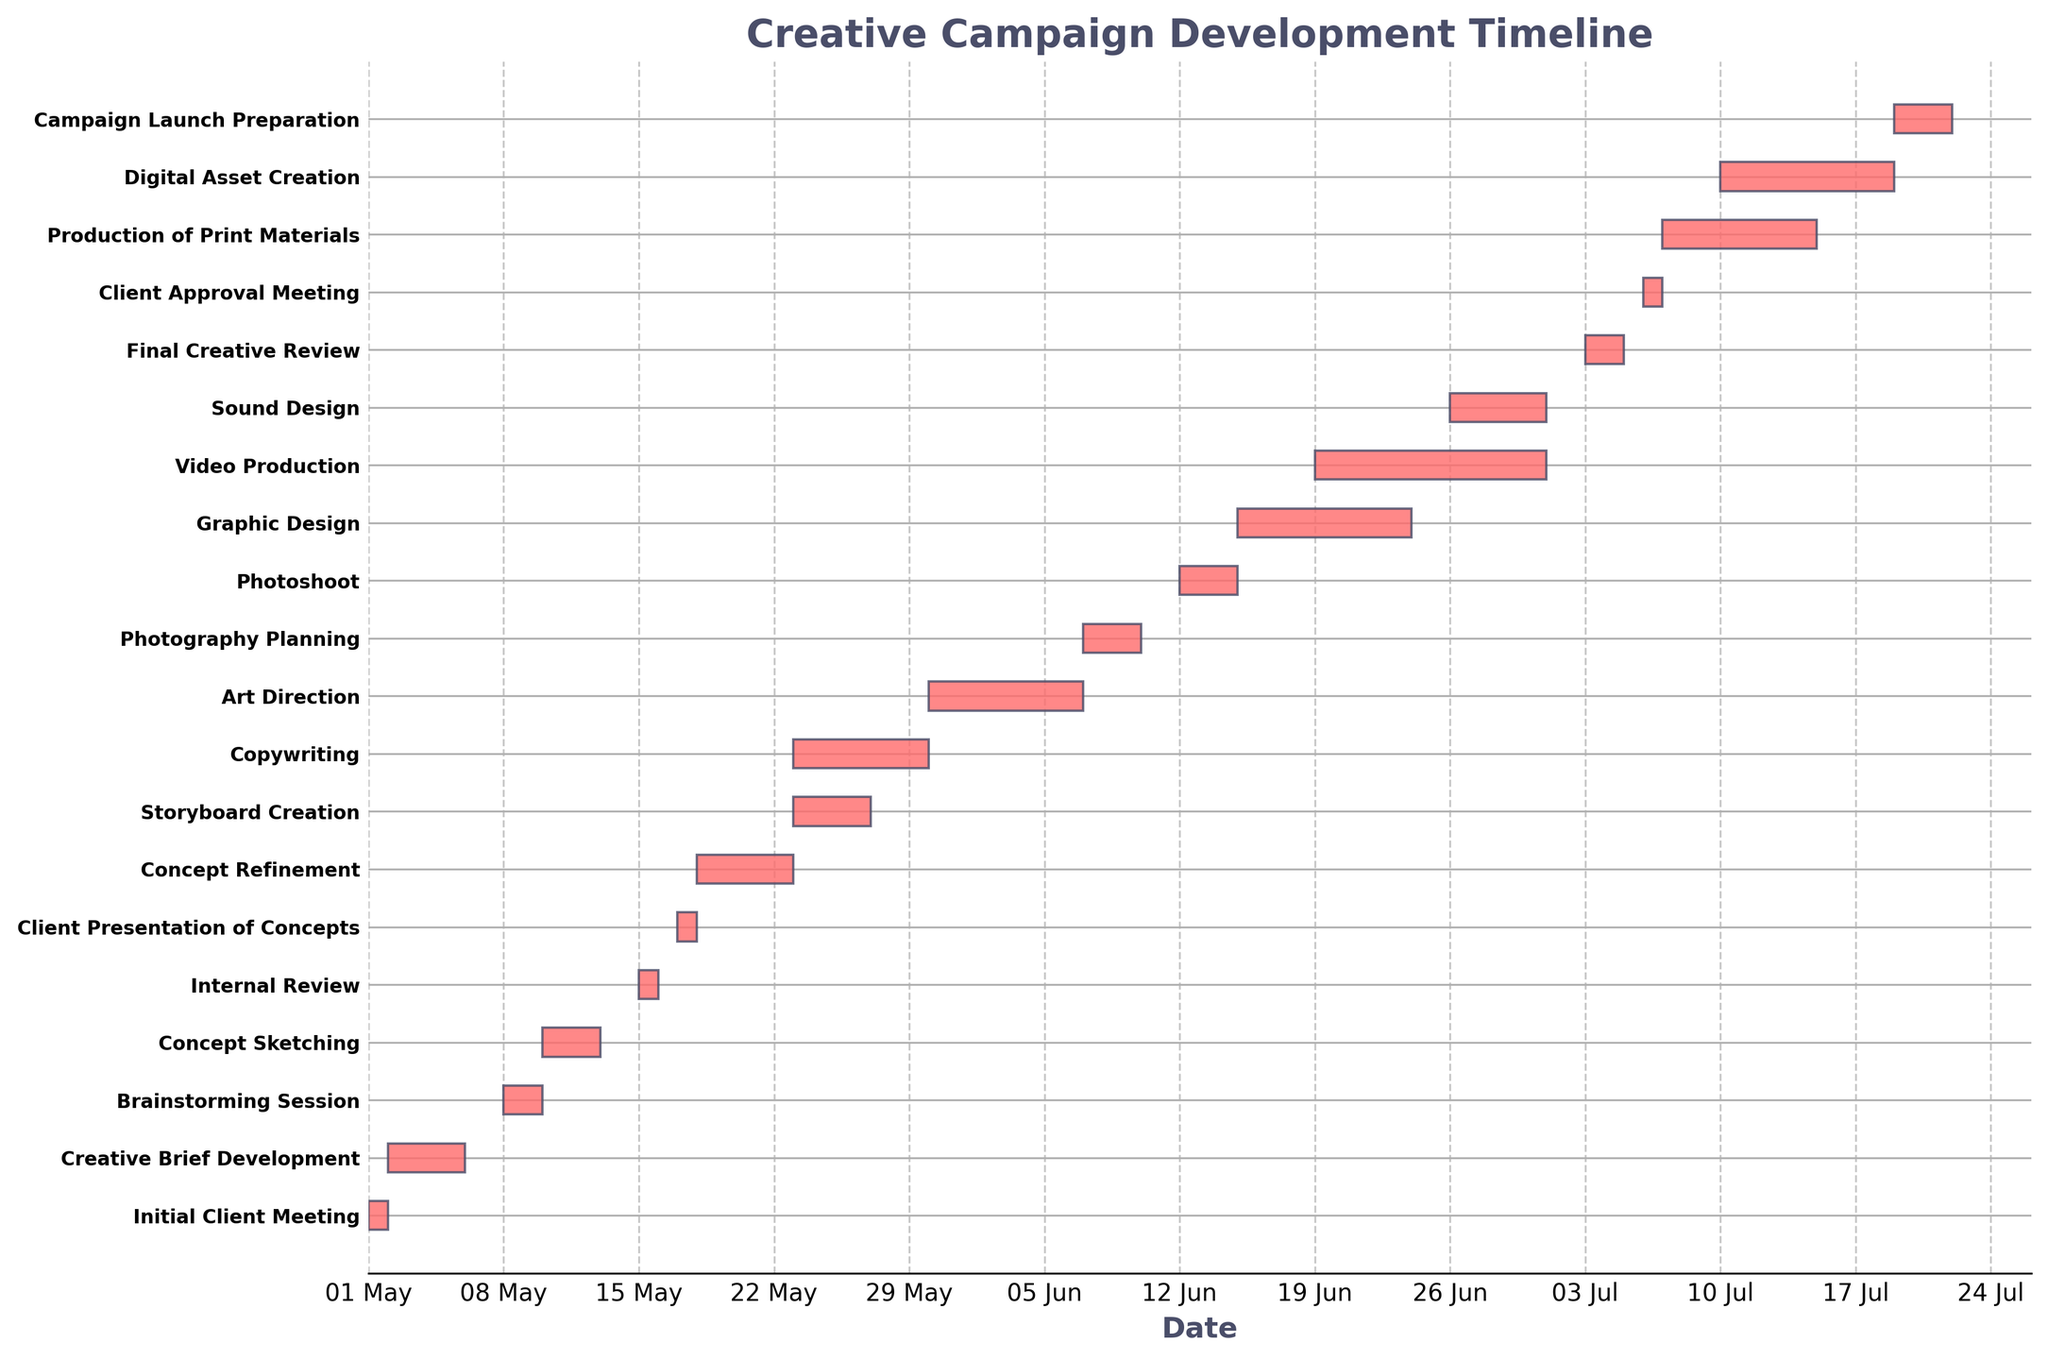Which task in the timeline takes the longest duration to complete? By visually inspecting the length of the horizontal bars, the task that spans the most days indicates the longest duration. The "Video Production" task extends the furthest along the timeline.
Answer: Video Production What is the total duration of the "Graphic Design" phase? Identify the start and end dates of the "Graphic Design" phase on the chart, which are June 15 and June 23 respectively. Calculate the total duration by subtracting the start date from the end date and adding one to include both start and end dates.
Answer: 9 days Which tasks overlap with the "Storyboard Creation" phase? Locate the "Storyboard Creation" bar on the timeline (May 23 to May 26) and check other bars that start or end within this range. Both "Copywriting" (May 23 to May 29) and "Concept Refinement" (May 18 to May 22) bars overlap with "Storyboard Creation".
Answer: Copywriting During which dates does the "Sound Design" phase occur? Find the "Sound Design" task on the y-axis and correlate it with its bar on the timeline. The start and end dates are June 26 to June 30.
Answer: June 26 - June 30 What is the total number of tasks represented in the timeline? Count the total number of tasks listed on the y-axis labels. The figure shows a unique task for each horizontal bar, and there are 21 tasks.
Answer: 21 tasks How many phases start in the month of May? Note the start date of each task and count those starting in May. Tasks starting in May are "Initial Client Meeting," "Creative Brief Development," "Brainstorming Session," "Concept Sketching," "Internal Review," "Client Presentation of Concepts," "Concept Refinement," "Storyboard Creation," and "Copywriting", making it a total of 9 tasks.
Answer: 9 tasks Which phase directly follows the "Client Approval Meeting"? Identify the "Client Approval Meeting" task and check the phase that starts immediately after its end date of July 6. The next task is the "Production of Print Materials," which starts on July 7.
Answer: Production of Print Materials How many tasks are scheduled to begin in June? Examine the start date of each task listed on the timeline and count those starting in June. The tasks are "Art Direction," "Photography Planning," "Photoshoot," "Graphic Design," "Video Production," and "Sound Design" totalling 6 tasks.
Answer: 6 tasks 